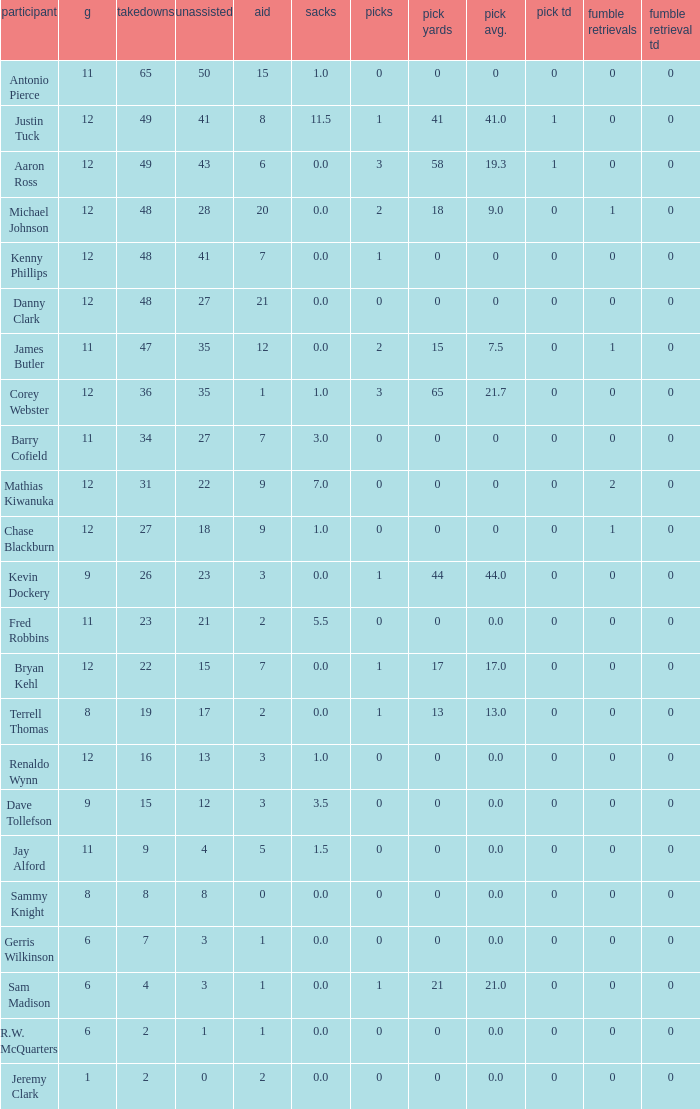What are the top tackles for 15.0. 